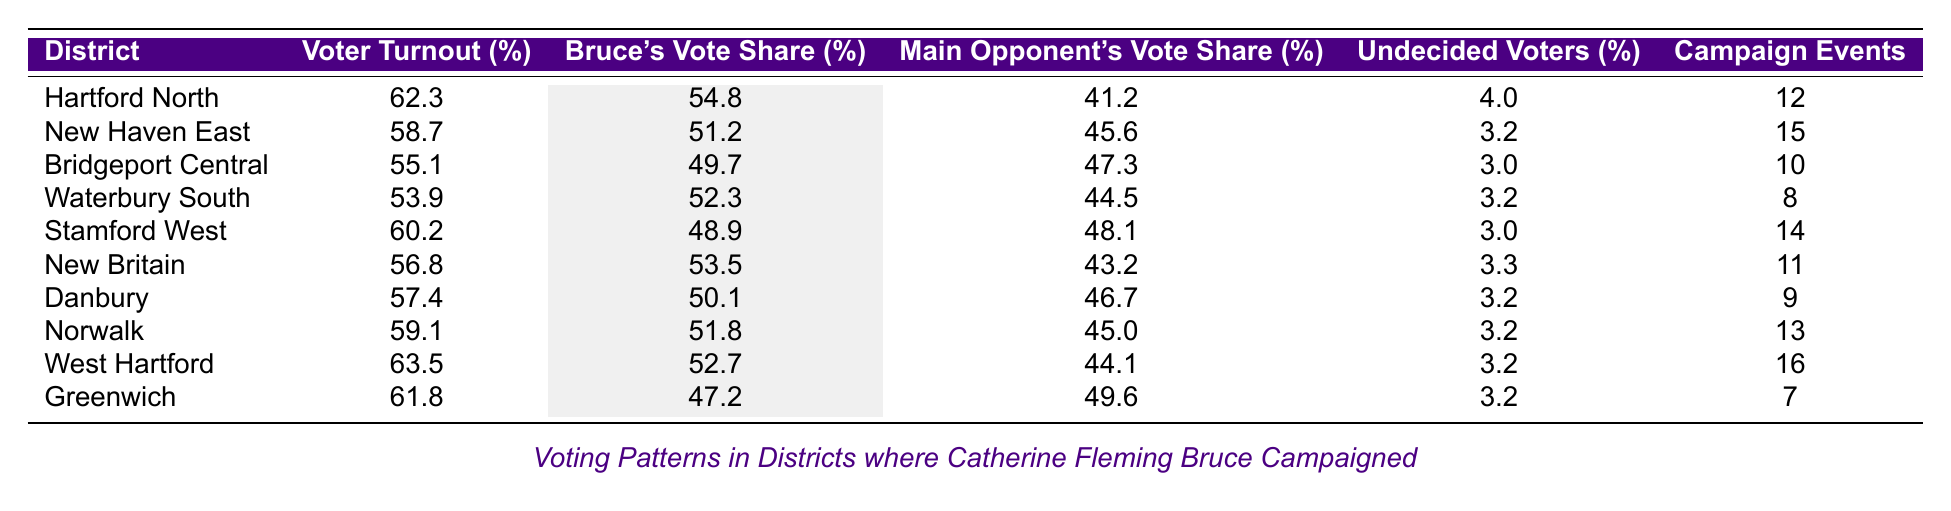What is the voter turnout percentage in Hartford North? The table lists Hartford North with a voter turnout percentage of 62.3%.
Answer: 62.3% What is Bruce's vote share in Bridgeport Central? According to the table, Bruce's vote share in Bridgeport Central is 49.7%.
Answer: 49.7% Which district had the highest voter turnout? By comparing the voter turnout percentages, West Hartford has the highest at 63.5%.
Answer: West Hartford What is the difference between Bruce's vote share and the main opponent's vote share in Waterbury South? Bruce's vote share in Waterbury South is 52.3%, and the main opponent's share is 44.5%. The difference is 52.3 - 44.5 = 7.8%.
Answer: 7.8% What is the average voter turnout percentage across all districts listed? To find the average, sum the voter turnout percentages (62.3 + 58.7 + 55.1 + 53.9 + 60.2 + 56.8 + 57.4 + 59.1 + 63.5 + 61.8) =  605.8. There are 10 districts, so the average is 605.8 / 10 = 60.58%.
Answer: 60.58% Is there a district where the number of campaign events held was greater than 15, but the voter turnout was less than 60%? New Haven East had 15 campaign events and a voter turnout of 58.7%, confirming that there is one such district.
Answer: Yes Which district had the lowest Bruce's vote share and how much was it? The lowest Bruce's vote share is in Greenwich at 47.2%.
Answer: Greenwich, 47.2% What percentage of voters were undecided in Stamford West? The table specifies that the percentage of undecided voters in Stamford West is 3.0%.
Answer: 3.0% How many more campaign events were held in Norwalk compared to Bridgeport Central? Norwalk had 13 campaign events and Bridgeport Central had 10, so the difference is 13 - 10 = 3 events.
Answer: 3 What is the combined vote share of Bruce and the main opponent in New Britain? Bruce's vote share is 53.5% and the main opponent's is 43.2%. Their combined share is 53.5 + 43.2 = 96.7%.
Answer: 96.7% 